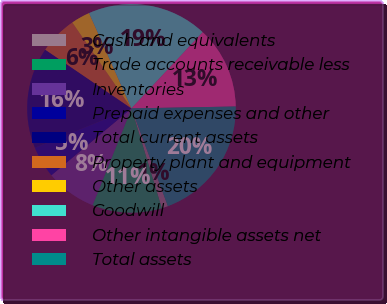Convert chart. <chart><loc_0><loc_0><loc_500><loc_500><pie_chart><fcel>Cash and equivalents<fcel>Trade accounts receivable less<fcel>Inventories<fcel>Prepaid expenses and other<fcel>Total current assets<fcel>Property plant and equipment<fcel>Other assets<fcel>Goodwill<fcel>Other intangible assets net<fcel>Total assets<nl><fcel>0.98%<fcel>10.78%<fcel>7.84%<fcel>4.9%<fcel>15.69%<fcel>5.88%<fcel>2.94%<fcel>18.63%<fcel>12.74%<fcel>19.61%<nl></chart> 